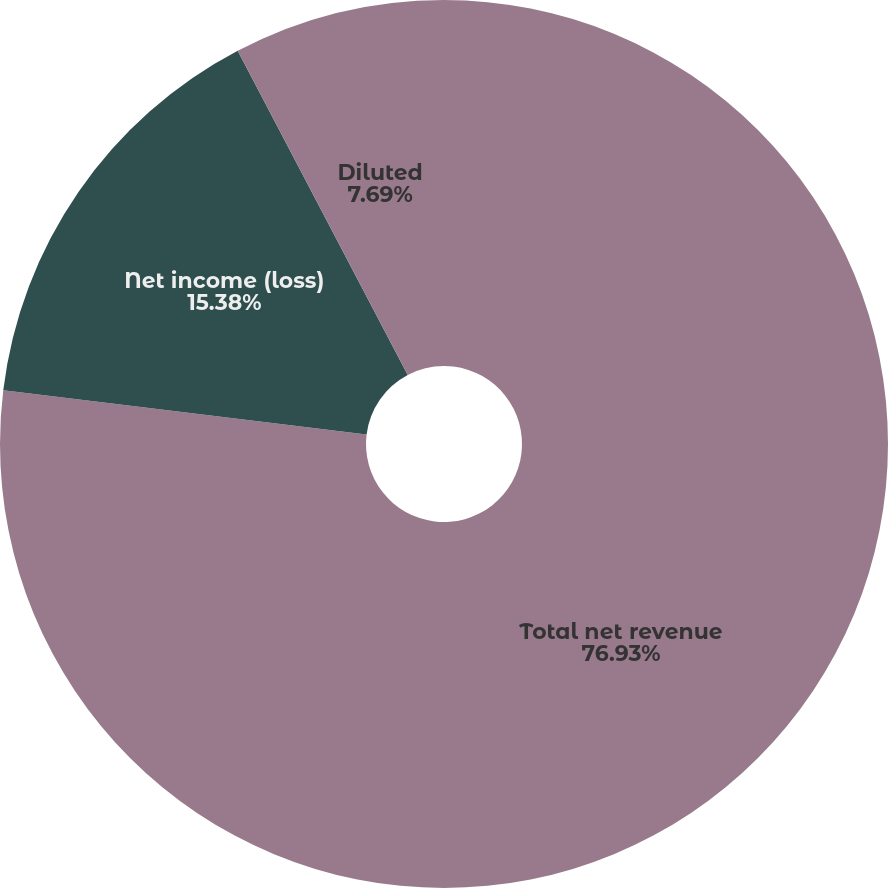Convert chart. <chart><loc_0><loc_0><loc_500><loc_500><pie_chart><fcel>Total net revenue<fcel>Net income (loss)<fcel>Basic<fcel>Diluted<nl><fcel>76.92%<fcel>15.38%<fcel>0.0%<fcel>7.69%<nl></chart> 